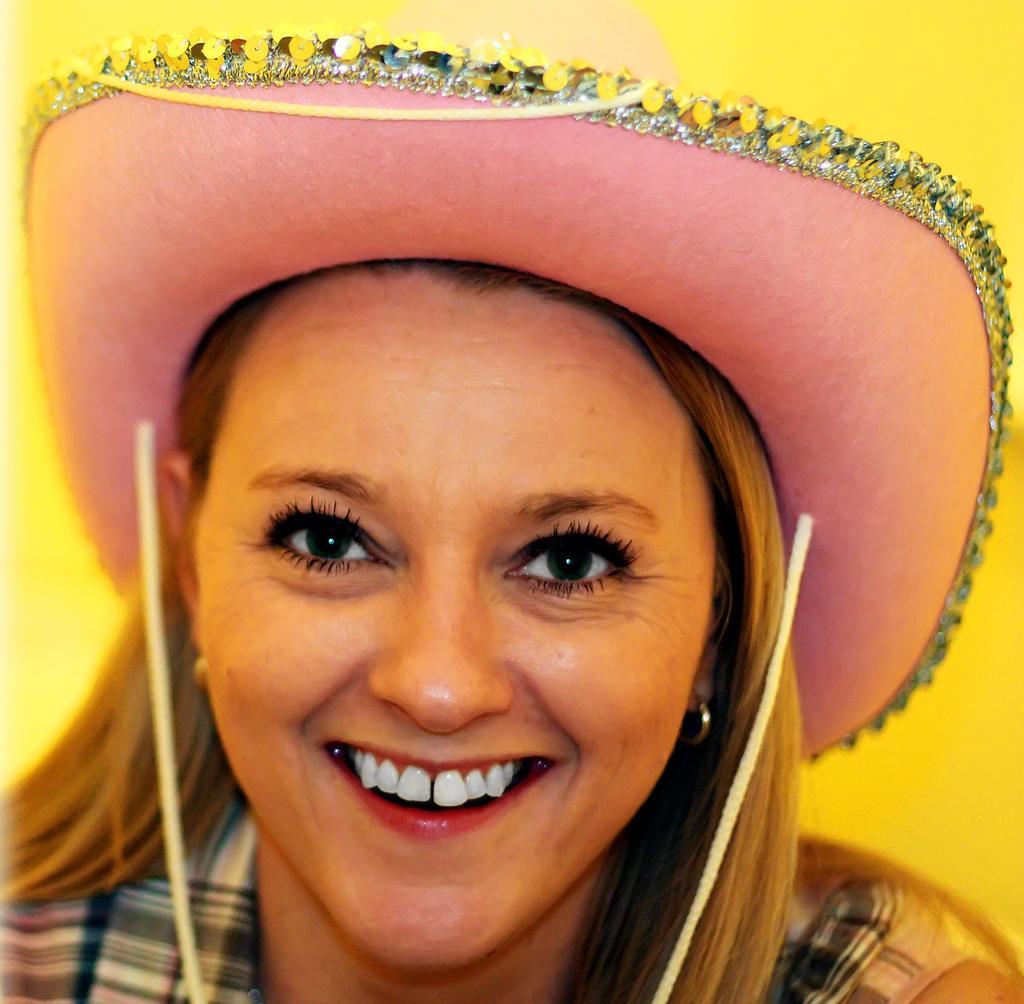Describe this image in one or two sentences. In this picture I can see a woman in front and I see that she is smiling. I can also see that she is wearing a hat and I see the yellow color background. 